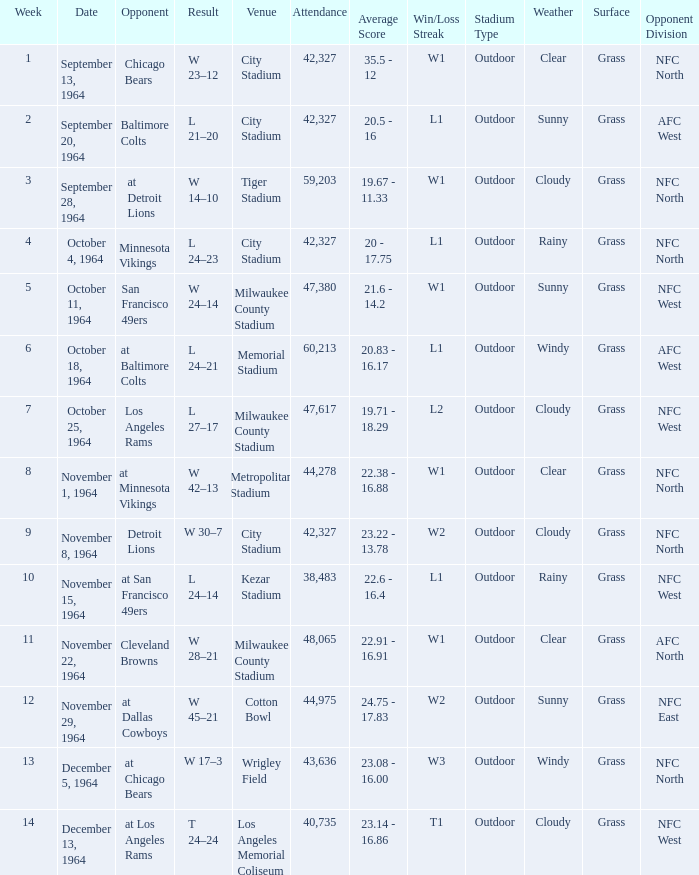What is the average attendance at a week 4 game? 42327.0. 